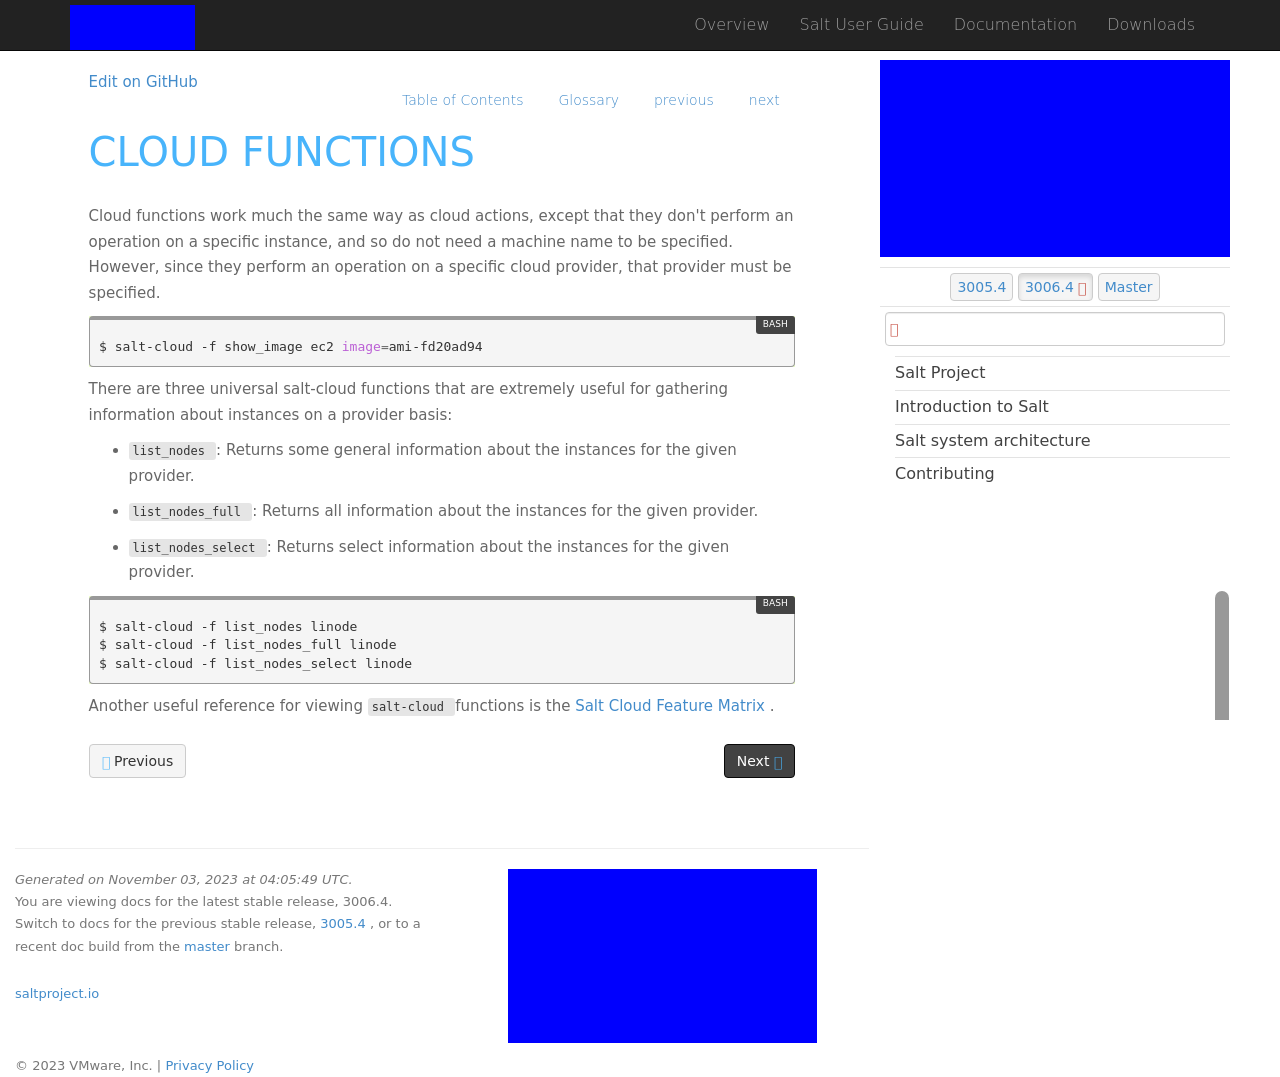Could you detail the process for assembling this website using HTML? To construct a website similar to the one depicted in the screenshot using HTML, you would need to layout the structure using HTML tags to define the content blocks such as headers, paragraphs, and divs. CSS would be used for styling to set the background colors, fonts, and layout as seen. JavaScript might be used to handle interactive elements such as drop-down menus. The source code shown in the initial example contains Bootstrap, which helps in creating responsive designs that work on mobile and desktop views efficiently. 